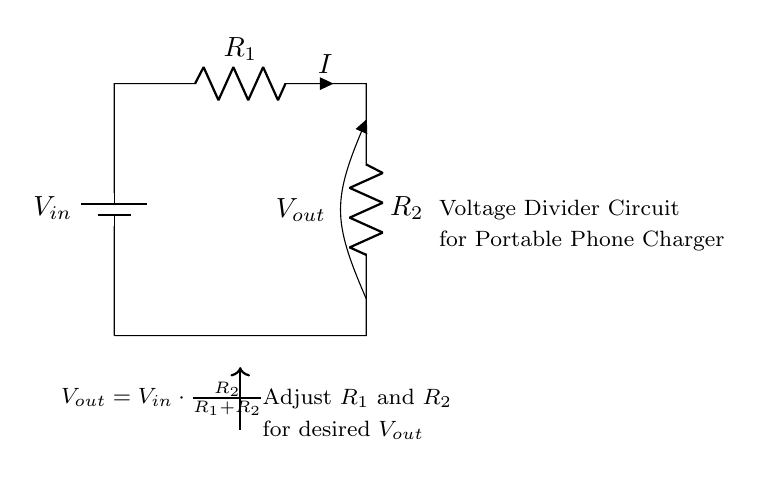What is the purpose of the circuit? The purpose of the circuit is to divide the input voltage into a lower output voltage. This is achieved by using two resistors in series, creating a voltage drop that is proportional to their resistance values.
Answer: To divide voltage What does the symbol Vout represent? Vout represents the output voltage across the resistor R2. It shows how much voltage can be extracted from the circuit for use in powering devices, such as a phone charger.
Answer: Output voltage How do you calculate Vout? Vout can be calculated using the formula Vout = Vin multiplied by the ratio of R2 to the sum of R1 and R2. This formula illustrates how the output voltage is determined by both resistors and the input voltage.
Answer: Vout = Vin * (R2 / (R1 + R2)) What happens if R1 is decreased? If R1 is decreased, the total resistance of the series circuit is reduced, which increases the current I and consequently raises the output voltage Vout, assuming Vin remains constant.
Answer: Vout increases What type of components are used in the circuit? The components used in the circuit include a battery, two resistors, and a node for measuring the output voltage. Each component plays a specific role in controlling the flow of current and voltage within the circuit.
Answer: Resistors and a battery What is the relationship between R1 and R2 for a specific output voltage? The relationship indicates that increasing R2 while keeping R1 constant will increase Vout, while increasing R1 will decrease Vout. This dependency must be managed to achieve the desired output voltage.
Answer: Directly affects Vout Which component directly influences the output voltage? The component that directly influences the output voltage is R2, as it is part of the voltage division formula, and changing its value impacts the resulting output voltage significantly.
Answer: R2 